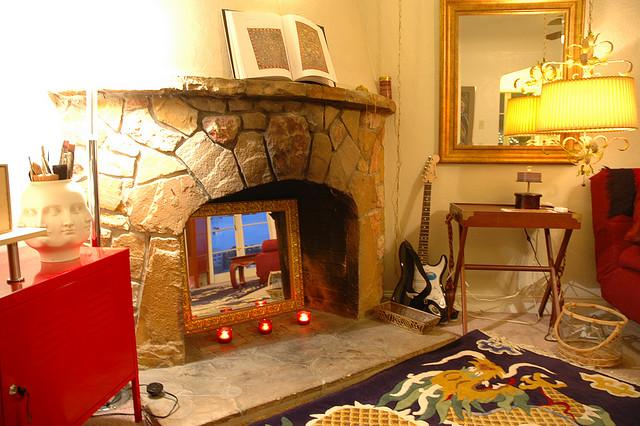What is the reflective object in the fireplace?
Concise answer only. Mirror. What is on top of the fireplace?
Be succinct. Book. What is next to the fireplace?
Give a very brief answer. Guitar. 